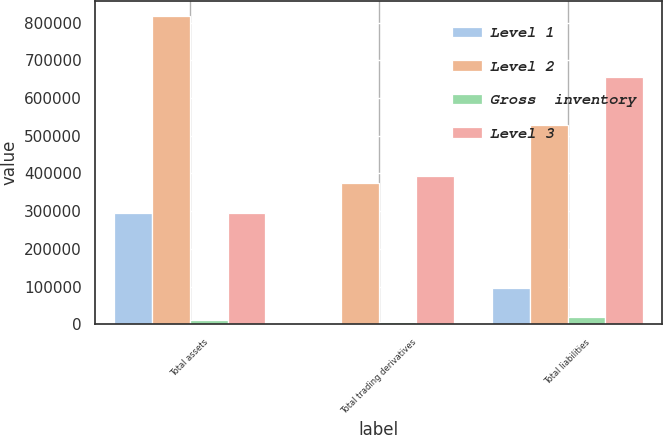Convert chart to OTSL. <chart><loc_0><loc_0><loc_500><loc_500><stacked_bar_chart><ecel><fcel>Total assets<fcel>Total trading derivatives<fcel>Total liabilities<nl><fcel>Level 1<fcel>294151<fcel>422<fcel>95133<nl><fcel>Level 2<fcel>818051<fcel>373654<fcel>528228<nl><fcel>Gross  inventory<fcel>10314<fcel>4954<fcel>19625<nl><fcel>Level 3<fcel>294151<fcel>392936<fcel>656892<nl></chart> 